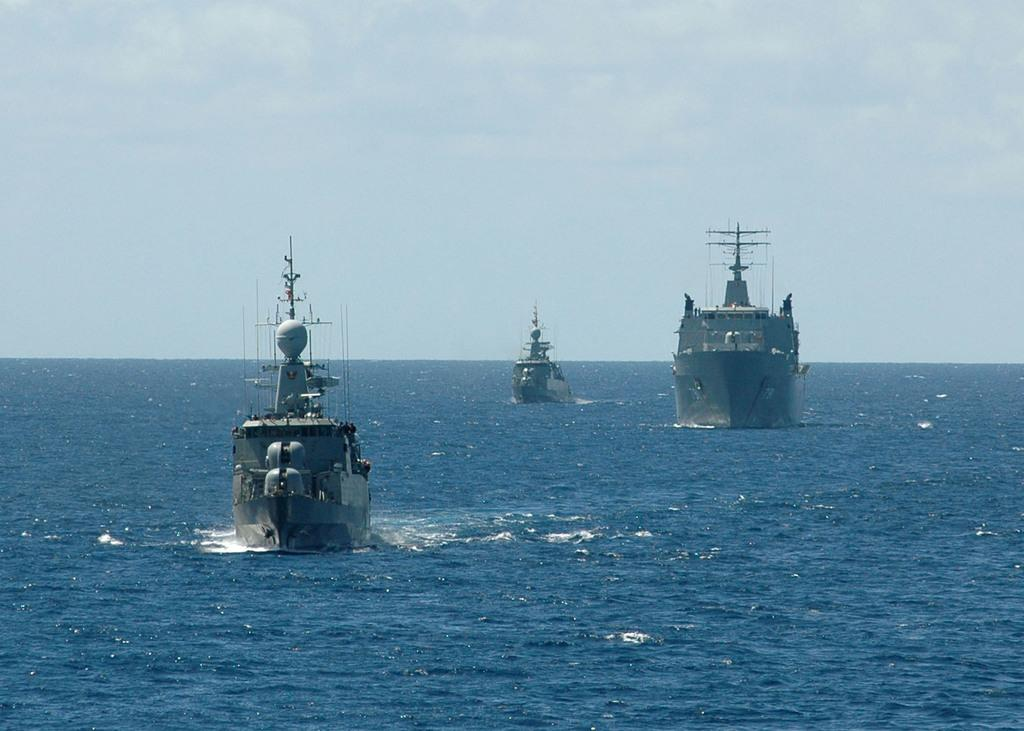What is the main subject of the image? The main subject of the image is ships. What color is the water in the image? The water in the image is blue. How would you describe the sky in the image? The sky in the image is blue and white. What type of lock can be seen securing the ships in the image? There is no lock visible in the image; it only shows ships on the water. 